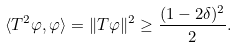<formula> <loc_0><loc_0><loc_500><loc_500>\langle T ^ { 2 } \varphi , \varphi \rangle = \| T \varphi \| ^ { 2 } \geq \frac { ( 1 - 2 \delta ) ^ { 2 } } { 2 } .</formula> 